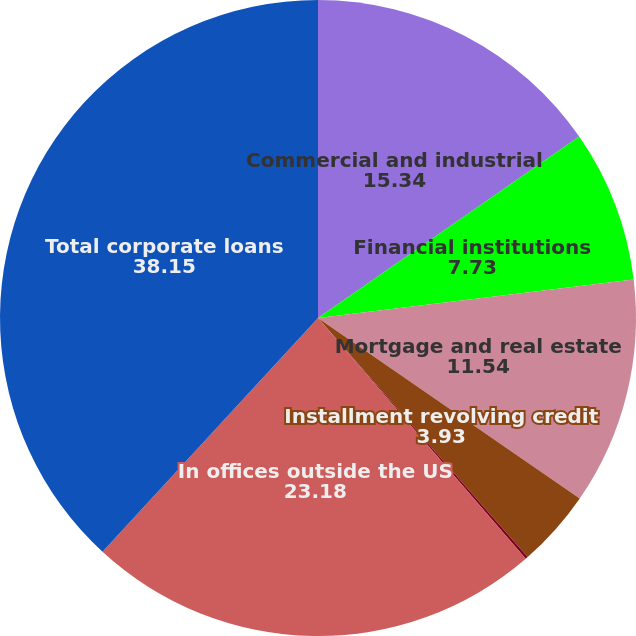Convert chart. <chart><loc_0><loc_0><loc_500><loc_500><pie_chart><fcel>Commercial and industrial<fcel>Financial institutions<fcel>Mortgage and real estate<fcel>Installment revolving credit<fcel>Lease financing<fcel>In offices outside the US<fcel>Total corporate loans<nl><fcel>15.34%<fcel>7.73%<fcel>11.54%<fcel>3.93%<fcel>0.13%<fcel>23.18%<fcel>38.15%<nl></chart> 